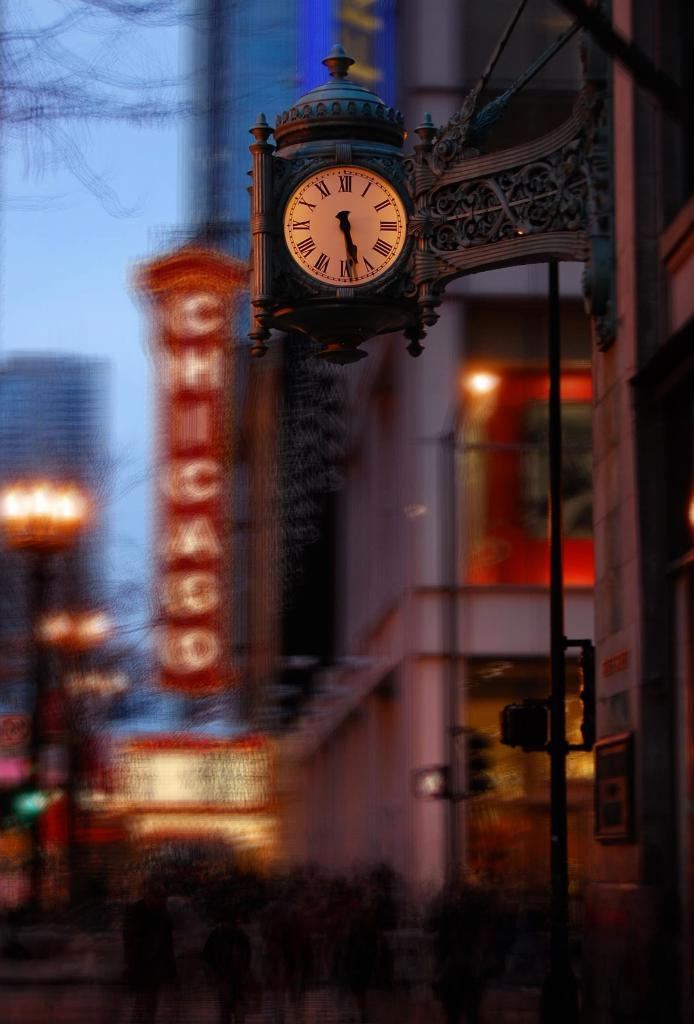<image>
Present a compact description of the photo's key features. A clock near a red Chicago sign hangs next to a street. 